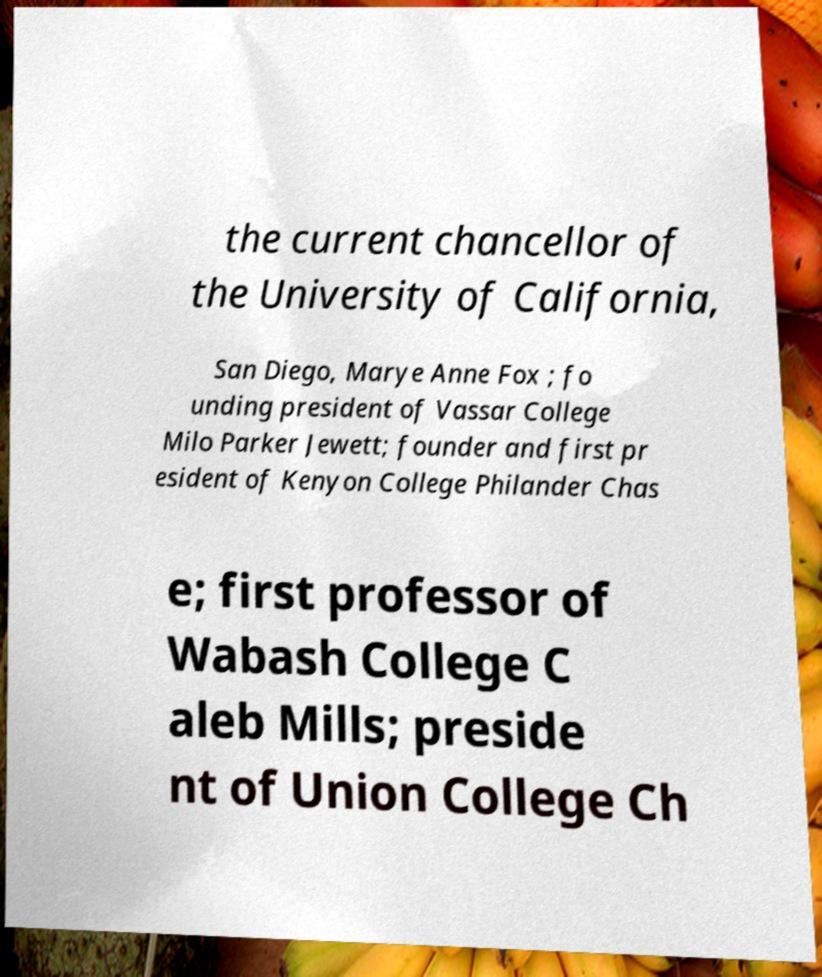Please read and relay the text visible in this image. What does it say? the current chancellor of the University of California, San Diego, Marye Anne Fox ; fo unding president of Vassar College Milo Parker Jewett; founder and first pr esident of Kenyon College Philander Chas e; first professor of Wabash College C aleb Mills; preside nt of Union College Ch 